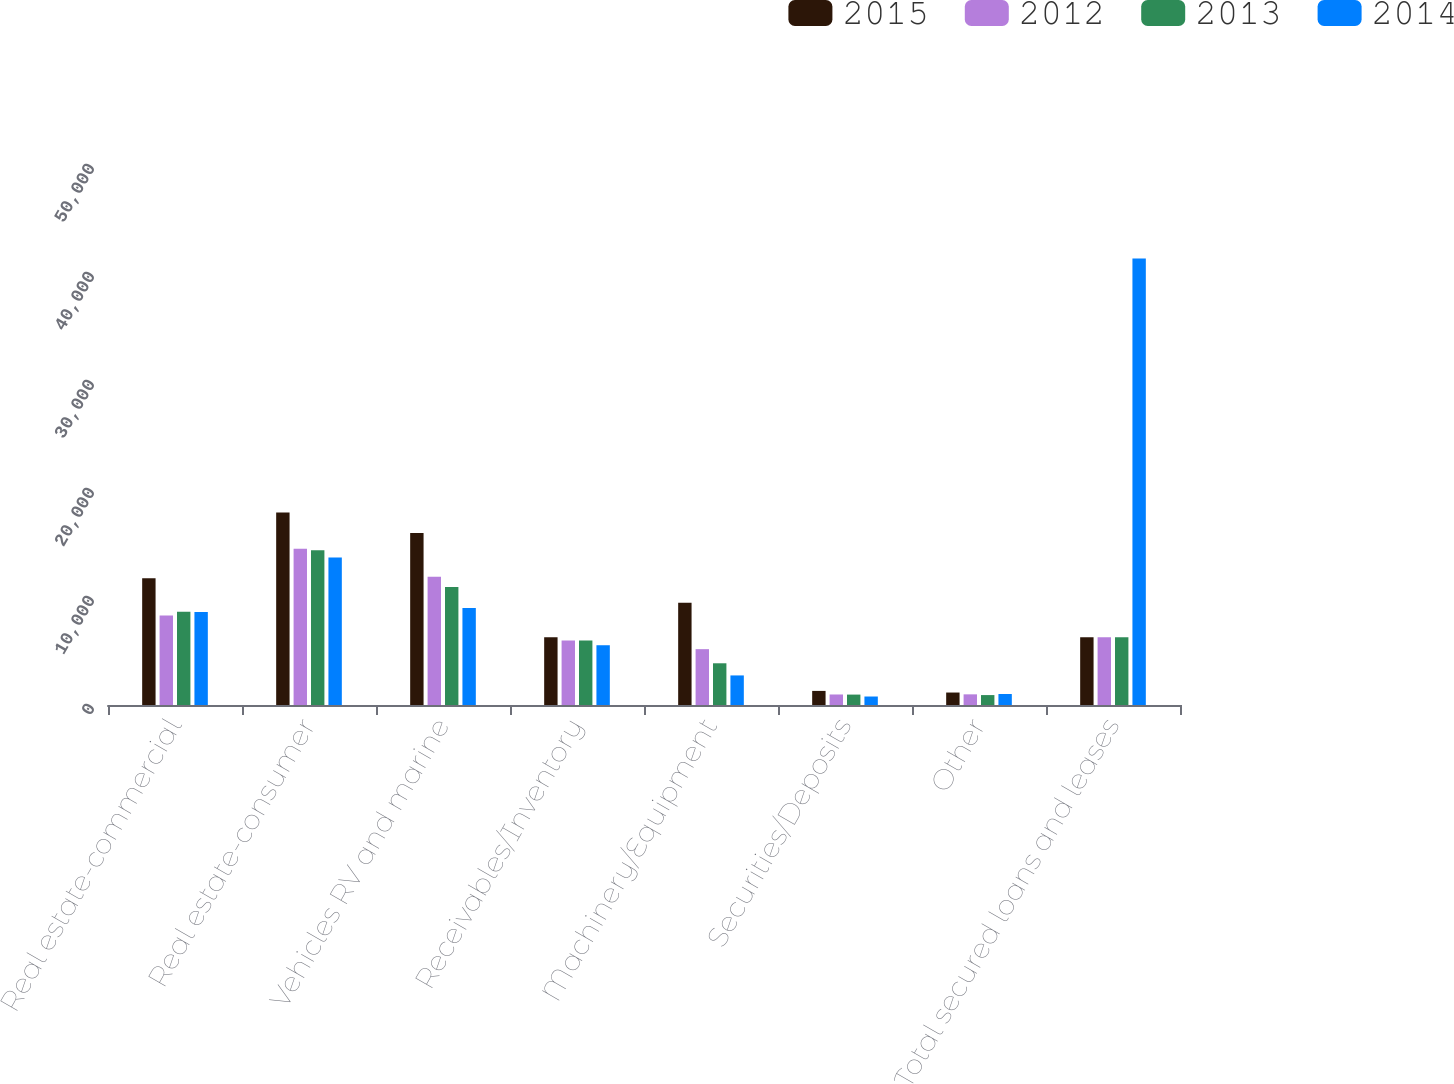Convert chart to OTSL. <chart><loc_0><loc_0><loc_500><loc_500><stacked_bar_chart><ecel><fcel>Real estate-commercial<fcel>Real estate-consumer<fcel>Vehicles RV and marine<fcel>Receivables/Inventory<fcel>Machinery/Equipment<fcel>Securities/Deposits<fcel>Other<fcel>Total secured loans and leases<nl><fcel>2015<fcel>11729<fcel>17831<fcel>15934<fcel>6277<fcel>9465<fcel>1305<fcel>1154<fcel>6277<nl><fcel>2012<fcel>8296<fcel>14469<fcel>11880<fcel>5961<fcel>5171<fcel>974<fcel>987<fcel>6277<nl><fcel>2013<fcel>8631<fcel>14322<fcel>10932<fcel>5968<fcel>3863<fcel>964<fcel>919<fcel>6277<nl><fcel>2014<fcel>8622<fcel>13657<fcel>8989<fcel>5534<fcel>2738<fcel>786<fcel>1016<fcel>41342<nl></chart> 